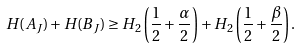<formula> <loc_0><loc_0><loc_500><loc_500>H ( A _ { J } ) + H ( B _ { J } ) \geq H _ { 2 } \left ( \frac { 1 } { 2 } + \frac { \alpha } { 2 } \right ) + H _ { 2 } \left ( \frac { 1 } { 2 } + \frac { \beta } { 2 } \right ) .</formula> 